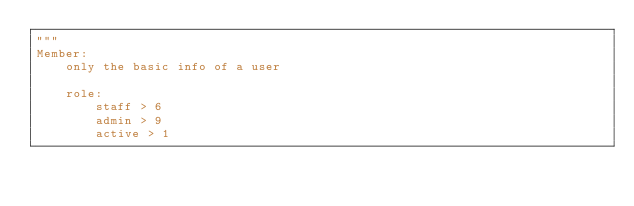<code> <loc_0><loc_0><loc_500><loc_500><_Python_>"""
Member:
    only the basic info of a user

    role:
        staff > 6
        admin > 9
        active > 1</code> 